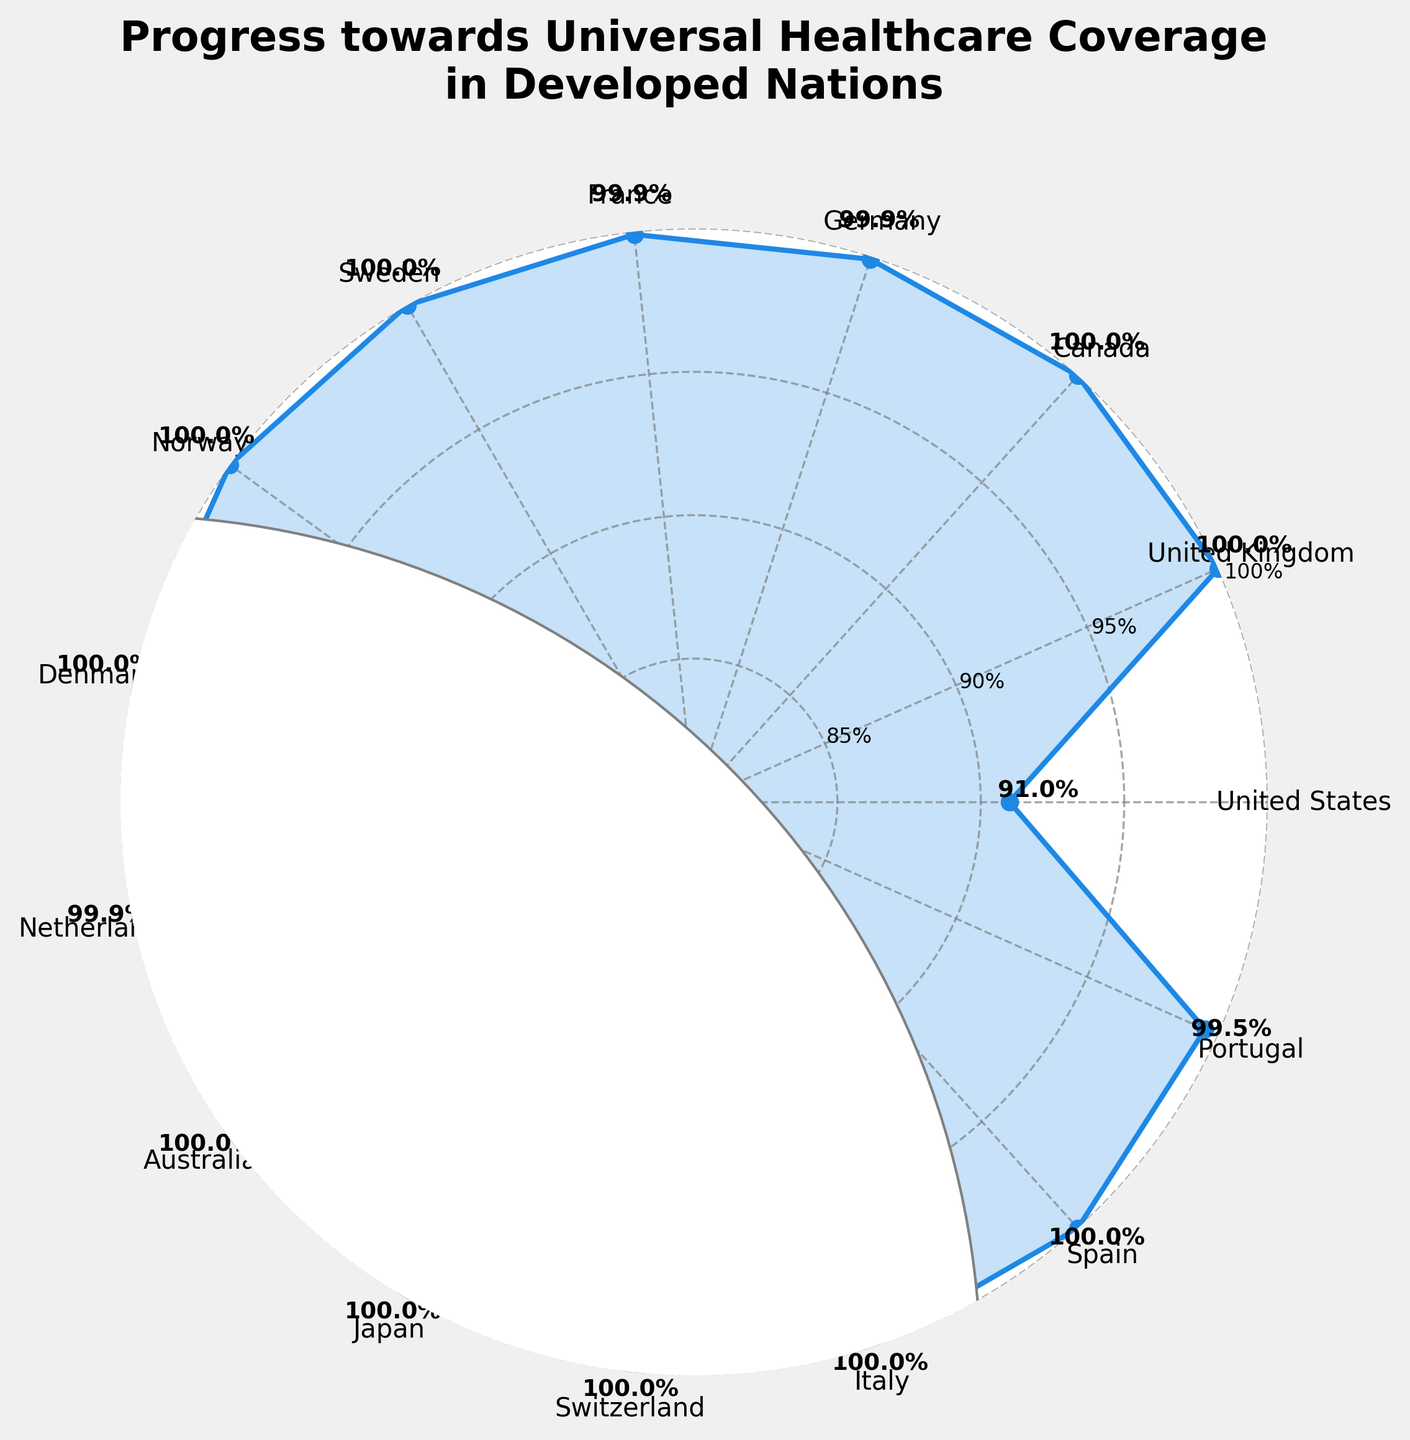How many countries have universal healthcare coverage in this figure? To determine the number of countries with universal healthcare coverage, we count those with 100% healthcare coverage.
Answer: 9 What’s the title of the plot? The title of the plot is displayed prominently at the top.
Answer: Progress towards Universal Healthcare Coverage in Developed Nations Which country has the lowest healthcare coverage? Identify the country with the smallest percentage of healthcare coverage by observing the values given.
Answer: United States What is the average healthcare coverage among the countries? The average is shown at the center of the plot; it's the mean value of the listed healthcare coverage percentages.
Answer: 99.7% How does the healthcare coverage in Germany compare to that in France? Both percentages are visible; compare the values to see which is higher or if they are equal.
Answer: Same (99.9%) What is the total number of countries represented in the plot? The number of countries can be counted from the labels around the plot's perimeter.
Answer: 15 Which countries have healthcare coverage precisely at 100%? List all countries that register 100% healthcare coverage by observing their values.
Answer: United Kingdom, Canada, Sweden, Norway, Denmark, Australia, Japan, Switzerland, Italy, Spain What is the difference in healthcare coverage between the United States and Portugal? Subtract the United States' percentage (91%) from Portugal's percentage (99.5%).
Answer: 8.5% What's the median healthcare coverage value among the countries represented? Arrange the healthcare coverage values in ascending order and find the middle value.
Answer: 100% How is the average healthcare coverage value determined and what is its value? Sum all the healthcare coverage values, divide by the number of countries, and compare with the value given in the center of the plot. Total = 1495.7, Number of countries = 15, thus average = 1495.7/15.
Answer: 99.7% 